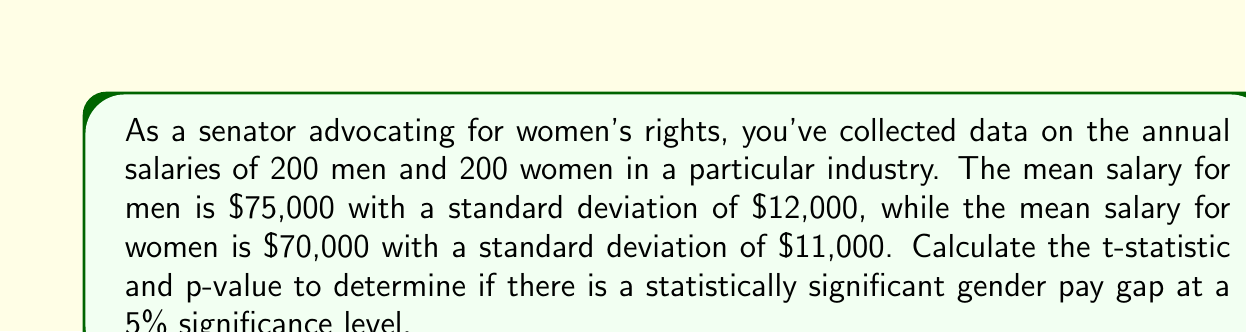Give your solution to this math problem. To determine if there is a statistically significant gender pay gap, we need to perform a two-sample t-test. We'll follow these steps:

1. Calculate the pooled standard deviation:
   $$s_p = \sqrt{\frac{(n_1 - 1)s_1^2 + (n_2 - 1)s_2^2}{n_1 + n_2 - 2}}$$
   where $n_1 = n_2 = 200$, $s_1 = 12000$, and $s_2 = 11000$

   $$s_p = \sqrt{\frac{(200 - 1)(12000)^2 + (200 - 1)(11000)^2}{200 + 200 - 2}}$$
   $$s_p = \sqrt{\frac{28728000000 + 24099000000}{398}} = 11513.96$$

2. Calculate the t-statistic:
   $$t = \frac{\bar{x}_1 - \bar{x}_2}{s_p \sqrt{\frac{2}{n}}}$$
   where $\bar{x}_1 = 75000$, $\bar{x}_2 = 70000$, and $n = 200$

   $$t = \frac{75000 - 70000}{11513.96 \sqrt{\frac{2}{200}}} = 4.34$$

3. Calculate the degrees of freedom:
   $$df = n_1 + n_2 - 2 = 200 + 200 - 2 = 398$$

4. Find the critical t-value for a two-tailed test at 5% significance level:
   Using a t-distribution table or calculator, we find:
   $$t_{critical} = \pm 1.966$$

5. Calculate the p-value:
   Using a t-distribution calculator or table, we find:
   $$p-value \approx 0.0000178$$

6. Compare the t-statistic to the critical t-value and the p-value to the significance level:
   $|4.34| > 1.966$ and $0.0000178 < 0.05$

Therefore, we reject the null hypothesis that there is no difference in mean salaries between men and women. The data suggests a statistically significant gender pay gap at the 5% significance level.
Answer: t-statistic: 4.34
p-value: 0.0000178
The gender pay gap is statistically significant at the 5% level. 